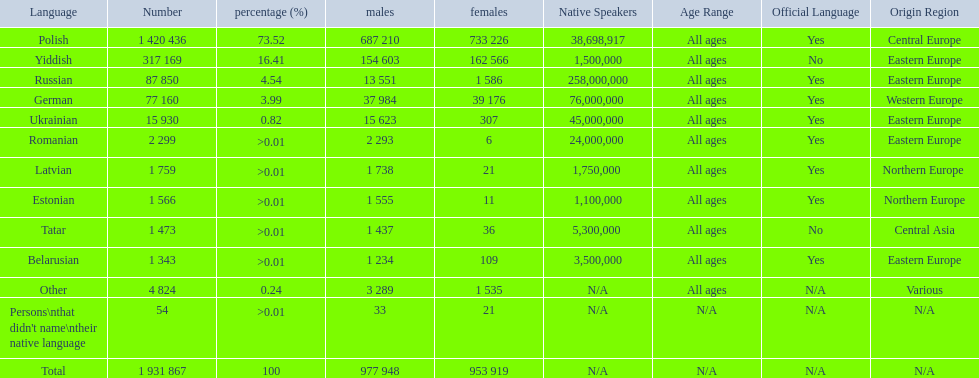What are all the languages? Polish, Yiddish, Russian, German, Ukrainian, Romanian, Latvian, Estonian, Tatar, Belarusian, Other. Which only have percentages >0.01? Romanian, Latvian, Estonian, Tatar, Belarusian. Of these, which has the greatest number of speakers? Romanian. 